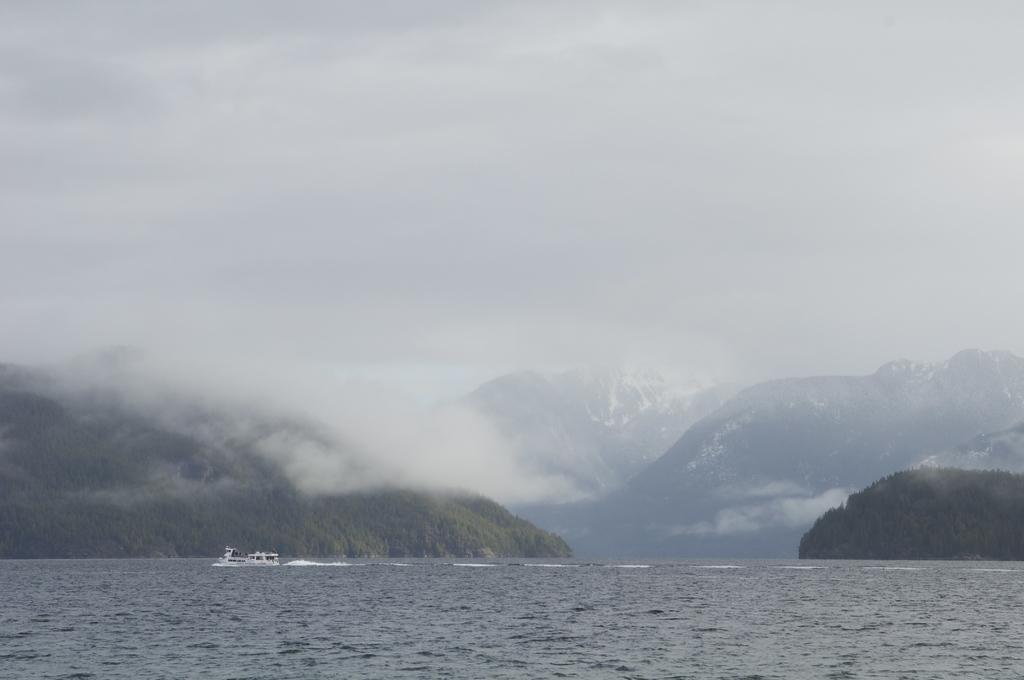Can you describe this image briefly? In this picture we can see a boat above the water. In the background of the image we can see trees, mountains, fog and sky. 